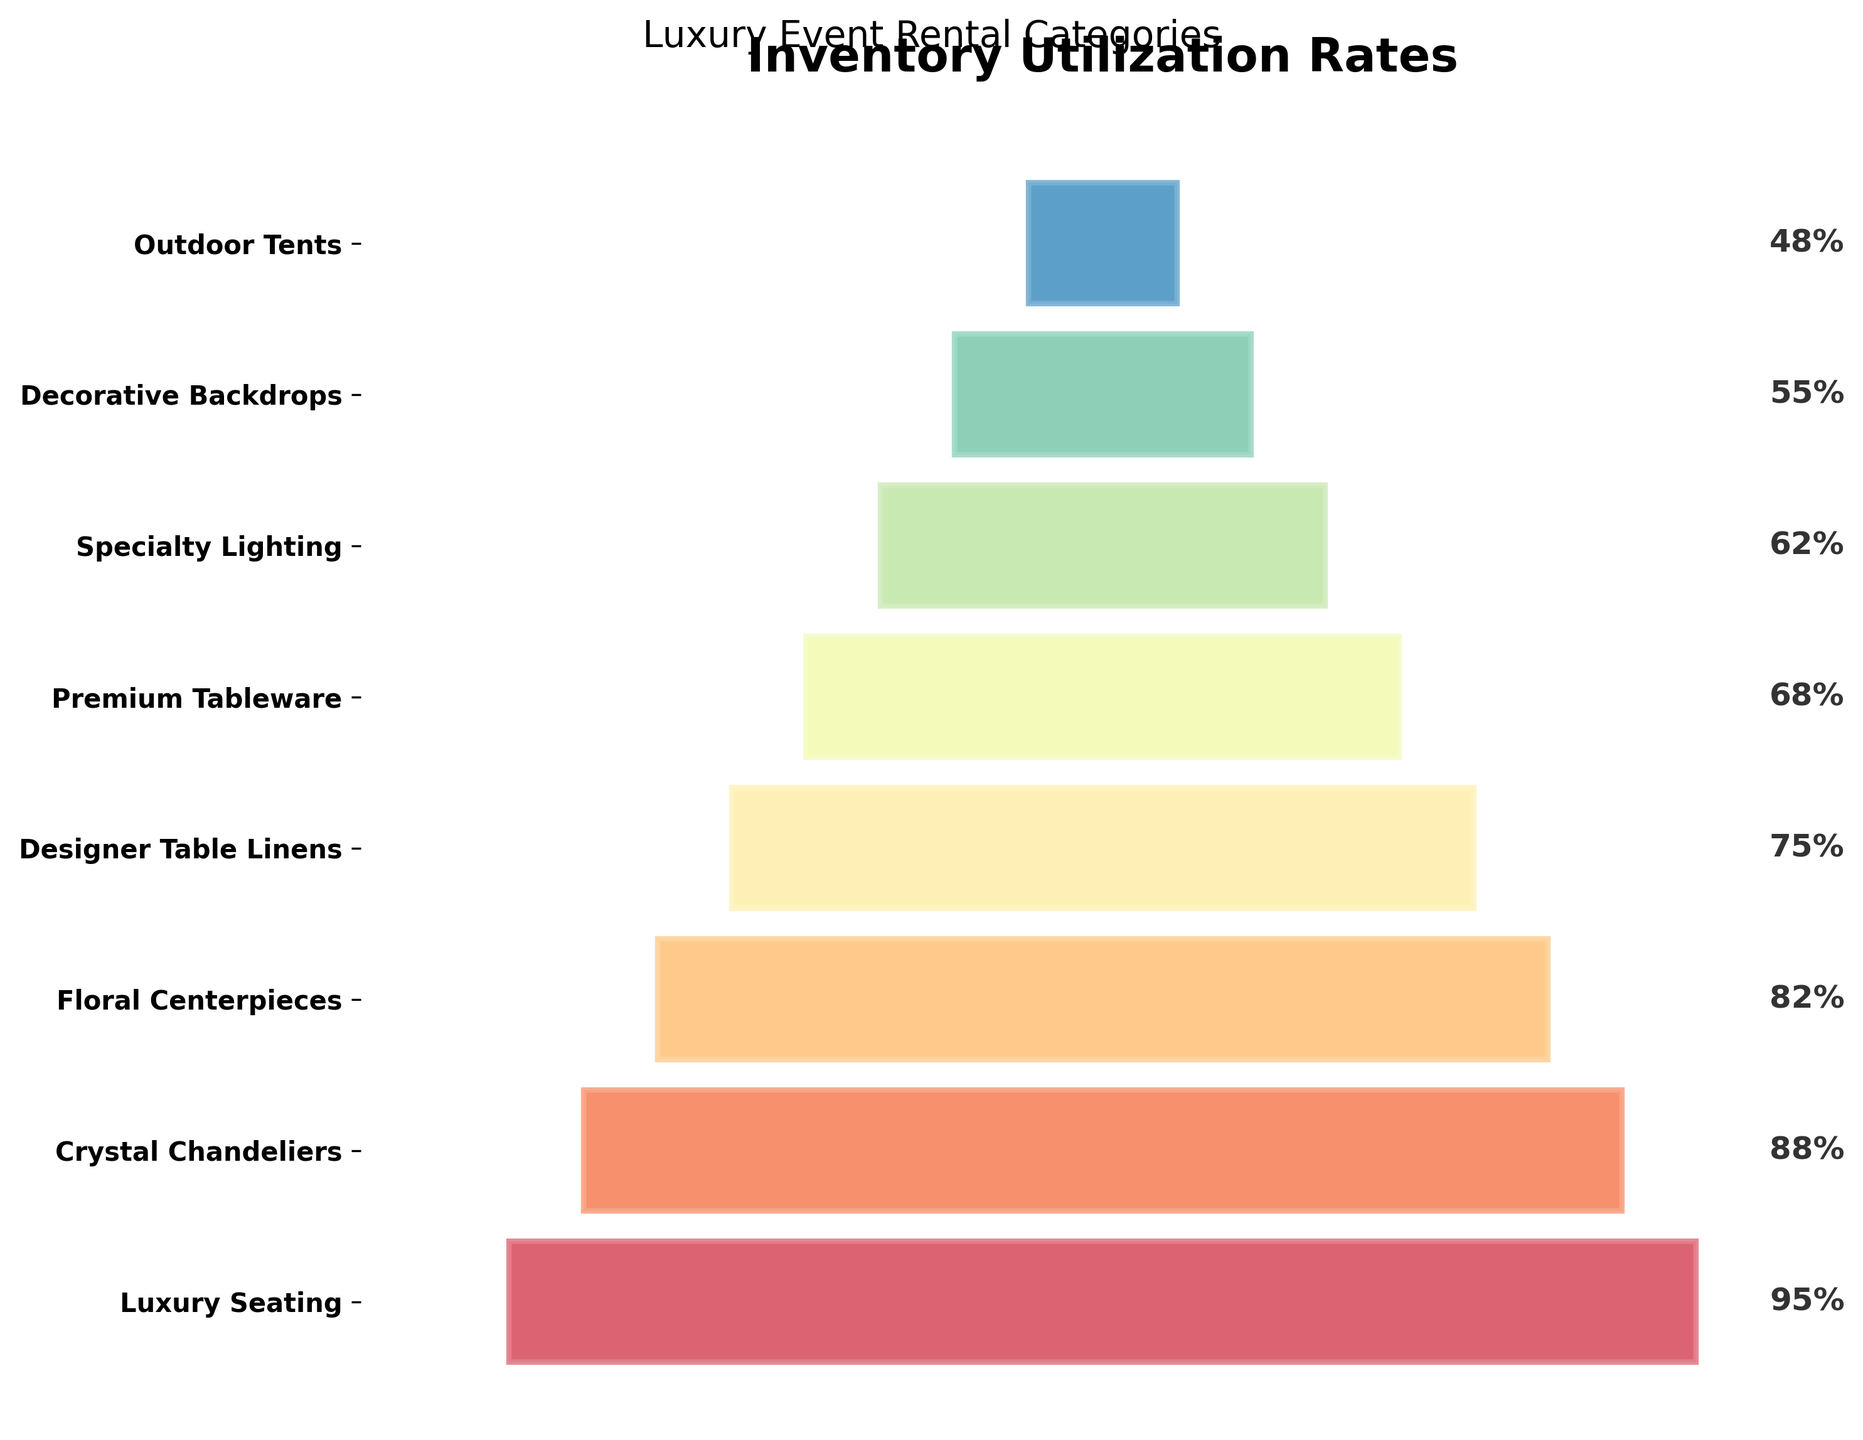What's the title of the funnel chart? The title of the chart is usually displayed at the top and is meant to give an overview of what the chart represents. In this case, the title is "Inventory Utilization Rates."
Answer: Inventory Utilization Rates Which category has the highest utilization rate? To find the category with the highest utilization rate, look for the bar that extends the furthest to the right. In this case, "Luxury Seating" has the longest bar.
Answer: Luxury Seating Which category has the lowest utilization rate? To find the category with the lowest utilization rate, look for the bar that extends the smallest distance to the right. In this chart, "Outdoor Tents" has the shortest bar.
Answer: Outdoor Tents Compare the utilization rates of "Crystal Chandeliers" and "Floral Centerpieces." Which one is higher and by how much? To compare the utilization rates of "Crystal Chandeliers" and "Floral Centerpieces," look at the length of their bars. "Crystal Chandeliers" has a utilization rate of 88%, and "Floral Centerpieces" has 82%. Subtract 82 from 88 to find the difference.
Answer: Crystal Chandeliers; 6% What's the average utilization rate of all categories? To find the average utilization rate, sum up the rates of all categories and then divide by the number of categories. (95 + 88 + 82 + 75 + 68 + 62 + 55 + 48) / 8 = 71.625
Answer: 71.625% Which category falls exactly in the middle when sorted by utilization rate? To find the median category, first, list all categories in order of their utilization rates: [48, 55, 62, 68, 75, 82, 88, 95]. The middle categories are "Designer Table Linens" and "Floral Centerpieces." Since there are an even number of categories, the average middle position corresponds to "Designer Table Linens."
Answer: Designer Table Linens What is the utilization rate of "Premium Tableware"? Simply look at the bar representing "Premium Tableware" and read off the utilization rate. According to the chart, it is labeled at 68%.
Answer: 68% Calculate the range of utilization rates observed in the chart. To calculate the range, subtract the lowest utilization rate from the highest. The highest rate is 95% for "Luxury Seating," and the lowest is 48% for "Outdoor Tents." Subtract 48 from 95 to get the range.
Answer: 47% What is the utilization rate difference between "Specialty Lighting" and "Decorative Backdrops"? Look at the bars for "Specialty Lighting" and "Decorative Backdrops." "Specialty Lighting" has a utilization rate of 62%, and "Decorative Backdrops" rate is 55%. The difference is 62 - 55.
Answer: 7% How many categories have a utilization rate of over 70%? Count the number of bars that extend past the 70% mark. The categories are "Luxury Seating," "Crystal Chandeliers," and "Floral Centerpieces."
Answer: 3 